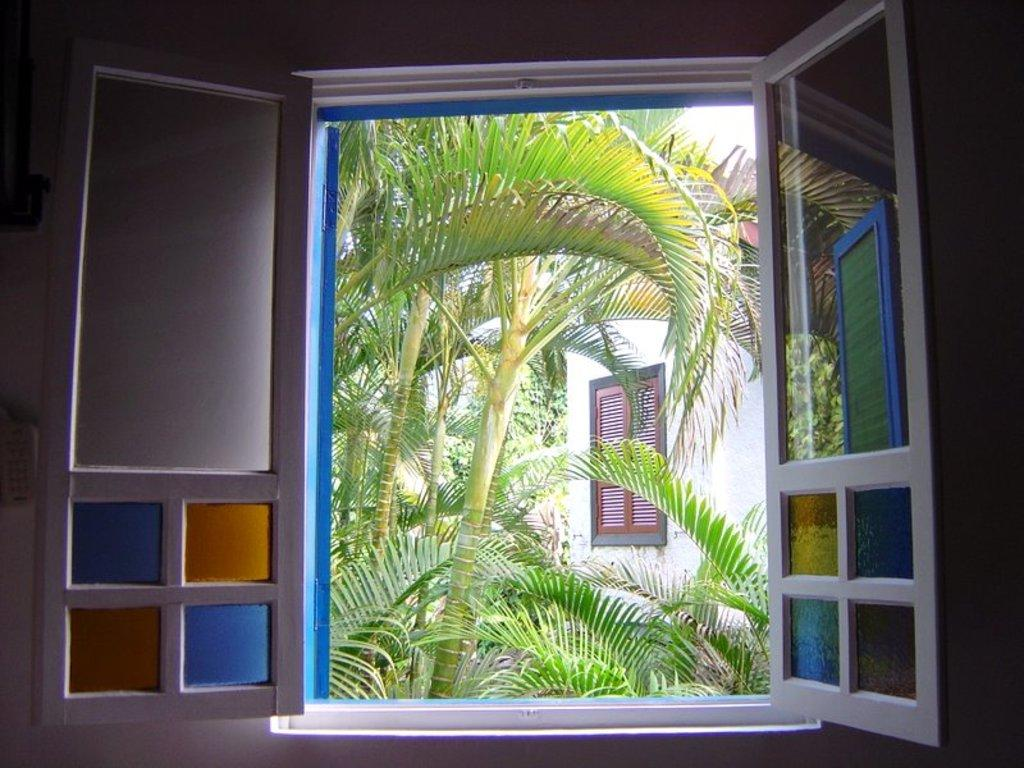What can be seen in the image that provides a view of the outside? There is a window in the image that provides a view of the outside. How many doors are visible in the front of the image? There are two doors visible in the front of the image. What can be seen through the window in the image? Trees and a building are visible through the window in the image. Is there another window visible through the window in the image? Yes, there is another window visible through the window in the image. Can you see a pig playing in the garden through the window in the image? There is no pig visible through the window in the image. Is the grandmother sitting on the porch in the image? There is no mention of a grandmother or a porch in the image. 